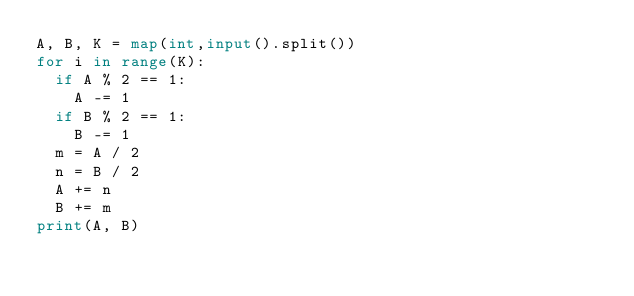Convert code to text. <code><loc_0><loc_0><loc_500><loc_500><_Python_>A, B, K = map(int,input().split())
for i in range(K):
  if A % 2 == 1:
    A -= 1
  if B % 2 == 1:
    B -= 1
  m = A / 2
  n = B / 2
  A += n
  B += m
print(A, B)</code> 